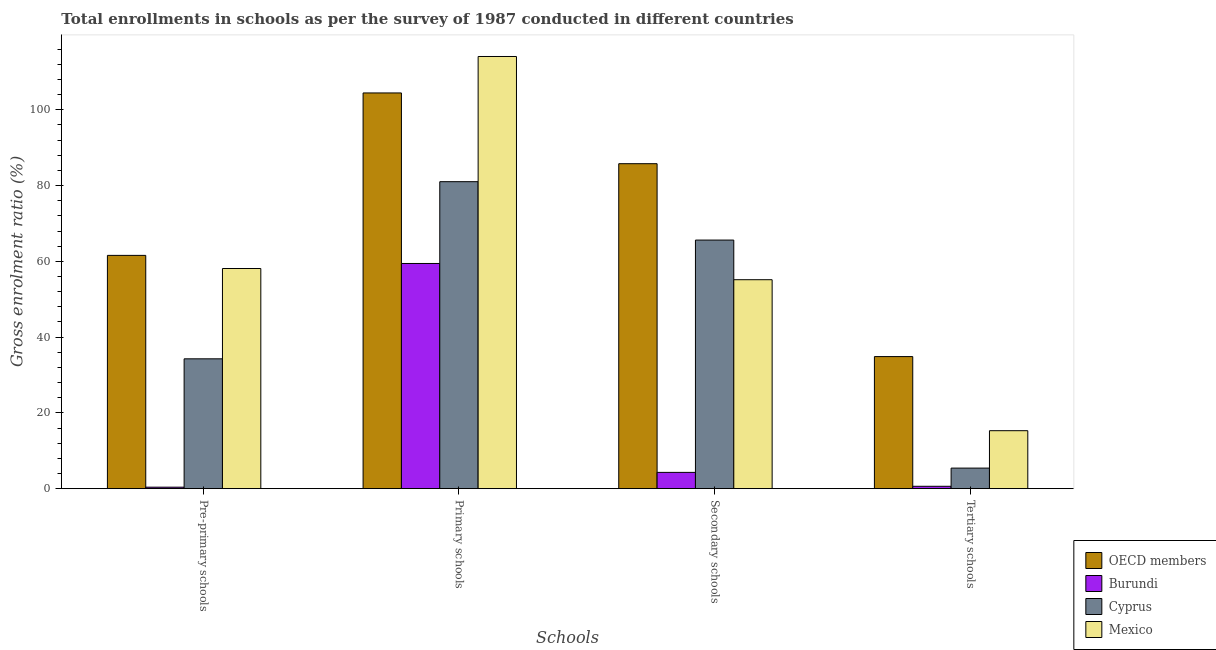How many different coloured bars are there?
Provide a succinct answer. 4. Are the number of bars per tick equal to the number of legend labels?
Provide a short and direct response. Yes. Are the number of bars on each tick of the X-axis equal?
Your response must be concise. Yes. How many bars are there on the 2nd tick from the left?
Keep it short and to the point. 4. What is the label of the 1st group of bars from the left?
Give a very brief answer. Pre-primary schools. What is the gross enrolment ratio in pre-primary schools in Cyprus?
Provide a succinct answer. 34.28. Across all countries, what is the maximum gross enrolment ratio in tertiary schools?
Your answer should be compact. 34.86. Across all countries, what is the minimum gross enrolment ratio in secondary schools?
Provide a succinct answer. 4.3. In which country was the gross enrolment ratio in secondary schools maximum?
Offer a terse response. OECD members. In which country was the gross enrolment ratio in pre-primary schools minimum?
Provide a short and direct response. Burundi. What is the total gross enrolment ratio in tertiary schools in the graph?
Provide a succinct answer. 56.23. What is the difference between the gross enrolment ratio in primary schools in OECD members and that in Cyprus?
Provide a short and direct response. 23.42. What is the difference between the gross enrolment ratio in tertiary schools in Burundi and the gross enrolment ratio in primary schools in Mexico?
Give a very brief answer. -113.45. What is the average gross enrolment ratio in pre-primary schools per country?
Give a very brief answer. 38.59. What is the difference between the gross enrolment ratio in secondary schools and gross enrolment ratio in primary schools in Cyprus?
Provide a succinct answer. -15.41. In how many countries, is the gross enrolment ratio in primary schools greater than 36 %?
Your answer should be very brief. 4. What is the ratio of the gross enrolment ratio in primary schools in Burundi to that in Mexico?
Your answer should be very brief. 0.52. Is the difference between the gross enrolment ratio in tertiary schools in Mexico and Burundi greater than the difference between the gross enrolment ratio in secondary schools in Mexico and Burundi?
Ensure brevity in your answer.  No. What is the difference between the highest and the second highest gross enrolment ratio in primary schools?
Keep it short and to the point. 9.62. What is the difference between the highest and the lowest gross enrolment ratio in secondary schools?
Offer a terse response. 81.48. What does the 3rd bar from the right in Pre-primary schools represents?
Make the answer very short. Burundi. How many bars are there?
Offer a very short reply. 16. Are all the bars in the graph horizontal?
Make the answer very short. No. What is the difference between two consecutive major ticks on the Y-axis?
Your response must be concise. 20. Are the values on the major ticks of Y-axis written in scientific E-notation?
Offer a terse response. No. Does the graph contain any zero values?
Your response must be concise. No. Does the graph contain grids?
Provide a succinct answer. No. How many legend labels are there?
Make the answer very short. 4. How are the legend labels stacked?
Make the answer very short. Vertical. What is the title of the graph?
Make the answer very short. Total enrollments in schools as per the survey of 1987 conducted in different countries. Does "Finland" appear as one of the legend labels in the graph?
Offer a very short reply. No. What is the label or title of the X-axis?
Give a very brief answer. Schools. What is the Gross enrolment ratio (%) in OECD members in Pre-primary schools?
Your answer should be compact. 61.58. What is the Gross enrolment ratio (%) in Burundi in Pre-primary schools?
Your response must be concise. 0.39. What is the Gross enrolment ratio (%) of Cyprus in Pre-primary schools?
Keep it short and to the point. 34.28. What is the Gross enrolment ratio (%) of Mexico in Pre-primary schools?
Provide a succinct answer. 58.11. What is the Gross enrolment ratio (%) in OECD members in Primary schools?
Offer a very short reply. 104.45. What is the Gross enrolment ratio (%) in Burundi in Primary schools?
Give a very brief answer. 59.44. What is the Gross enrolment ratio (%) in Cyprus in Primary schools?
Ensure brevity in your answer.  81.03. What is the Gross enrolment ratio (%) of Mexico in Primary schools?
Your answer should be very brief. 114.08. What is the Gross enrolment ratio (%) of OECD members in Secondary schools?
Offer a terse response. 85.78. What is the Gross enrolment ratio (%) of Burundi in Secondary schools?
Offer a terse response. 4.3. What is the Gross enrolment ratio (%) in Cyprus in Secondary schools?
Make the answer very short. 65.62. What is the Gross enrolment ratio (%) in Mexico in Secondary schools?
Ensure brevity in your answer.  55.15. What is the Gross enrolment ratio (%) of OECD members in Tertiary schools?
Your response must be concise. 34.86. What is the Gross enrolment ratio (%) of Burundi in Tertiary schools?
Offer a very short reply. 0.63. What is the Gross enrolment ratio (%) in Cyprus in Tertiary schools?
Make the answer very short. 5.43. What is the Gross enrolment ratio (%) in Mexico in Tertiary schools?
Your answer should be compact. 15.31. Across all Schools, what is the maximum Gross enrolment ratio (%) of OECD members?
Offer a terse response. 104.45. Across all Schools, what is the maximum Gross enrolment ratio (%) in Burundi?
Provide a succinct answer. 59.44. Across all Schools, what is the maximum Gross enrolment ratio (%) in Cyprus?
Offer a very short reply. 81.03. Across all Schools, what is the maximum Gross enrolment ratio (%) in Mexico?
Offer a terse response. 114.08. Across all Schools, what is the minimum Gross enrolment ratio (%) in OECD members?
Your answer should be very brief. 34.86. Across all Schools, what is the minimum Gross enrolment ratio (%) of Burundi?
Provide a succinct answer. 0.39. Across all Schools, what is the minimum Gross enrolment ratio (%) of Cyprus?
Keep it short and to the point. 5.43. Across all Schools, what is the minimum Gross enrolment ratio (%) in Mexico?
Offer a terse response. 15.31. What is the total Gross enrolment ratio (%) of OECD members in the graph?
Your answer should be compact. 286.68. What is the total Gross enrolment ratio (%) of Burundi in the graph?
Ensure brevity in your answer.  64.76. What is the total Gross enrolment ratio (%) of Cyprus in the graph?
Offer a terse response. 186.35. What is the total Gross enrolment ratio (%) of Mexico in the graph?
Give a very brief answer. 242.65. What is the difference between the Gross enrolment ratio (%) in OECD members in Pre-primary schools and that in Primary schools?
Keep it short and to the point. -42.88. What is the difference between the Gross enrolment ratio (%) of Burundi in Pre-primary schools and that in Primary schools?
Make the answer very short. -59.05. What is the difference between the Gross enrolment ratio (%) of Cyprus in Pre-primary schools and that in Primary schools?
Your response must be concise. -46.75. What is the difference between the Gross enrolment ratio (%) in Mexico in Pre-primary schools and that in Primary schools?
Your answer should be very brief. -55.96. What is the difference between the Gross enrolment ratio (%) in OECD members in Pre-primary schools and that in Secondary schools?
Your response must be concise. -24.2. What is the difference between the Gross enrolment ratio (%) in Burundi in Pre-primary schools and that in Secondary schools?
Provide a short and direct response. -3.91. What is the difference between the Gross enrolment ratio (%) of Cyprus in Pre-primary schools and that in Secondary schools?
Provide a succinct answer. -31.34. What is the difference between the Gross enrolment ratio (%) in Mexico in Pre-primary schools and that in Secondary schools?
Give a very brief answer. 2.96. What is the difference between the Gross enrolment ratio (%) of OECD members in Pre-primary schools and that in Tertiary schools?
Provide a short and direct response. 26.71. What is the difference between the Gross enrolment ratio (%) in Burundi in Pre-primary schools and that in Tertiary schools?
Ensure brevity in your answer.  -0.23. What is the difference between the Gross enrolment ratio (%) in Cyprus in Pre-primary schools and that in Tertiary schools?
Offer a terse response. 28.85. What is the difference between the Gross enrolment ratio (%) in Mexico in Pre-primary schools and that in Tertiary schools?
Your answer should be compact. 42.81. What is the difference between the Gross enrolment ratio (%) in OECD members in Primary schools and that in Secondary schools?
Offer a very short reply. 18.67. What is the difference between the Gross enrolment ratio (%) of Burundi in Primary schools and that in Secondary schools?
Your response must be concise. 55.14. What is the difference between the Gross enrolment ratio (%) in Cyprus in Primary schools and that in Secondary schools?
Your response must be concise. 15.41. What is the difference between the Gross enrolment ratio (%) of Mexico in Primary schools and that in Secondary schools?
Your answer should be compact. 58.92. What is the difference between the Gross enrolment ratio (%) of OECD members in Primary schools and that in Tertiary schools?
Give a very brief answer. 69.59. What is the difference between the Gross enrolment ratio (%) in Burundi in Primary schools and that in Tertiary schools?
Give a very brief answer. 58.81. What is the difference between the Gross enrolment ratio (%) in Cyprus in Primary schools and that in Tertiary schools?
Provide a short and direct response. 75.6. What is the difference between the Gross enrolment ratio (%) in Mexico in Primary schools and that in Tertiary schools?
Keep it short and to the point. 98.77. What is the difference between the Gross enrolment ratio (%) in OECD members in Secondary schools and that in Tertiary schools?
Keep it short and to the point. 50.92. What is the difference between the Gross enrolment ratio (%) of Burundi in Secondary schools and that in Tertiary schools?
Make the answer very short. 3.67. What is the difference between the Gross enrolment ratio (%) of Cyprus in Secondary schools and that in Tertiary schools?
Your answer should be compact. 60.19. What is the difference between the Gross enrolment ratio (%) in Mexico in Secondary schools and that in Tertiary schools?
Your answer should be compact. 39.85. What is the difference between the Gross enrolment ratio (%) of OECD members in Pre-primary schools and the Gross enrolment ratio (%) of Burundi in Primary schools?
Make the answer very short. 2.14. What is the difference between the Gross enrolment ratio (%) of OECD members in Pre-primary schools and the Gross enrolment ratio (%) of Cyprus in Primary schools?
Keep it short and to the point. -19.45. What is the difference between the Gross enrolment ratio (%) in OECD members in Pre-primary schools and the Gross enrolment ratio (%) in Mexico in Primary schools?
Make the answer very short. -52.5. What is the difference between the Gross enrolment ratio (%) in Burundi in Pre-primary schools and the Gross enrolment ratio (%) in Cyprus in Primary schools?
Ensure brevity in your answer.  -80.64. What is the difference between the Gross enrolment ratio (%) of Burundi in Pre-primary schools and the Gross enrolment ratio (%) of Mexico in Primary schools?
Keep it short and to the point. -113.68. What is the difference between the Gross enrolment ratio (%) of Cyprus in Pre-primary schools and the Gross enrolment ratio (%) of Mexico in Primary schools?
Your answer should be very brief. -79.8. What is the difference between the Gross enrolment ratio (%) in OECD members in Pre-primary schools and the Gross enrolment ratio (%) in Burundi in Secondary schools?
Provide a succinct answer. 57.28. What is the difference between the Gross enrolment ratio (%) of OECD members in Pre-primary schools and the Gross enrolment ratio (%) of Cyprus in Secondary schools?
Keep it short and to the point. -4.04. What is the difference between the Gross enrolment ratio (%) of OECD members in Pre-primary schools and the Gross enrolment ratio (%) of Mexico in Secondary schools?
Offer a terse response. 6.42. What is the difference between the Gross enrolment ratio (%) of Burundi in Pre-primary schools and the Gross enrolment ratio (%) of Cyprus in Secondary schools?
Provide a short and direct response. -65.22. What is the difference between the Gross enrolment ratio (%) in Burundi in Pre-primary schools and the Gross enrolment ratio (%) in Mexico in Secondary schools?
Give a very brief answer. -54.76. What is the difference between the Gross enrolment ratio (%) in Cyprus in Pre-primary schools and the Gross enrolment ratio (%) in Mexico in Secondary schools?
Your response must be concise. -20.88. What is the difference between the Gross enrolment ratio (%) in OECD members in Pre-primary schools and the Gross enrolment ratio (%) in Burundi in Tertiary schools?
Your answer should be very brief. 60.95. What is the difference between the Gross enrolment ratio (%) in OECD members in Pre-primary schools and the Gross enrolment ratio (%) in Cyprus in Tertiary schools?
Your answer should be very brief. 56.15. What is the difference between the Gross enrolment ratio (%) of OECD members in Pre-primary schools and the Gross enrolment ratio (%) of Mexico in Tertiary schools?
Ensure brevity in your answer.  46.27. What is the difference between the Gross enrolment ratio (%) in Burundi in Pre-primary schools and the Gross enrolment ratio (%) in Cyprus in Tertiary schools?
Keep it short and to the point. -5.04. What is the difference between the Gross enrolment ratio (%) in Burundi in Pre-primary schools and the Gross enrolment ratio (%) in Mexico in Tertiary schools?
Provide a short and direct response. -14.91. What is the difference between the Gross enrolment ratio (%) of Cyprus in Pre-primary schools and the Gross enrolment ratio (%) of Mexico in Tertiary schools?
Keep it short and to the point. 18.97. What is the difference between the Gross enrolment ratio (%) in OECD members in Primary schools and the Gross enrolment ratio (%) in Burundi in Secondary schools?
Your answer should be compact. 100.15. What is the difference between the Gross enrolment ratio (%) in OECD members in Primary schools and the Gross enrolment ratio (%) in Cyprus in Secondary schools?
Make the answer very short. 38.84. What is the difference between the Gross enrolment ratio (%) in OECD members in Primary schools and the Gross enrolment ratio (%) in Mexico in Secondary schools?
Your answer should be very brief. 49.3. What is the difference between the Gross enrolment ratio (%) in Burundi in Primary schools and the Gross enrolment ratio (%) in Cyprus in Secondary schools?
Ensure brevity in your answer.  -6.18. What is the difference between the Gross enrolment ratio (%) in Burundi in Primary schools and the Gross enrolment ratio (%) in Mexico in Secondary schools?
Ensure brevity in your answer.  4.29. What is the difference between the Gross enrolment ratio (%) in Cyprus in Primary schools and the Gross enrolment ratio (%) in Mexico in Secondary schools?
Your answer should be compact. 25.88. What is the difference between the Gross enrolment ratio (%) in OECD members in Primary schools and the Gross enrolment ratio (%) in Burundi in Tertiary schools?
Offer a very short reply. 103.82. What is the difference between the Gross enrolment ratio (%) in OECD members in Primary schools and the Gross enrolment ratio (%) in Cyprus in Tertiary schools?
Your answer should be compact. 99.02. What is the difference between the Gross enrolment ratio (%) of OECD members in Primary schools and the Gross enrolment ratio (%) of Mexico in Tertiary schools?
Make the answer very short. 89.15. What is the difference between the Gross enrolment ratio (%) of Burundi in Primary schools and the Gross enrolment ratio (%) of Cyprus in Tertiary schools?
Ensure brevity in your answer.  54.01. What is the difference between the Gross enrolment ratio (%) in Burundi in Primary schools and the Gross enrolment ratio (%) in Mexico in Tertiary schools?
Your answer should be very brief. 44.14. What is the difference between the Gross enrolment ratio (%) of Cyprus in Primary schools and the Gross enrolment ratio (%) of Mexico in Tertiary schools?
Your response must be concise. 65.72. What is the difference between the Gross enrolment ratio (%) in OECD members in Secondary schools and the Gross enrolment ratio (%) in Burundi in Tertiary schools?
Provide a succinct answer. 85.15. What is the difference between the Gross enrolment ratio (%) of OECD members in Secondary schools and the Gross enrolment ratio (%) of Cyprus in Tertiary schools?
Ensure brevity in your answer.  80.35. What is the difference between the Gross enrolment ratio (%) in OECD members in Secondary schools and the Gross enrolment ratio (%) in Mexico in Tertiary schools?
Give a very brief answer. 70.47. What is the difference between the Gross enrolment ratio (%) in Burundi in Secondary schools and the Gross enrolment ratio (%) in Cyprus in Tertiary schools?
Keep it short and to the point. -1.13. What is the difference between the Gross enrolment ratio (%) of Burundi in Secondary schools and the Gross enrolment ratio (%) of Mexico in Tertiary schools?
Your answer should be very brief. -11.01. What is the difference between the Gross enrolment ratio (%) of Cyprus in Secondary schools and the Gross enrolment ratio (%) of Mexico in Tertiary schools?
Give a very brief answer. 50.31. What is the average Gross enrolment ratio (%) of OECD members per Schools?
Make the answer very short. 71.67. What is the average Gross enrolment ratio (%) in Burundi per Schools?
Provide a succinct answer. 16.19. What is the average Gross enrolment ratio (%) in Cyprus per Schools?
Make the answer very short. 46.59. What is the average Gross enrolment ratio (%) in Mexico per Schools?
Your answer should be compact. 60.66. What is the difference between the Gross enrolment ratio (%) of OECD members and Gross enrolment ratio (%) of Burundi in Pre-primary schools?
Make the answer very short. 61.18. What is the difference between the Gross enrolment ratio (%) of OECD members and Gross enrolment ratio (%) of Cyprus in Pre-primary schools?
Make the answer very short. 27.3. What is the difference between the Gross enrolment ratio (%) of OECD members and Gross enrolment ratio (%) of Mexico in Pre-primary schools?
Give a very brief answer. 3.46. What is the difference between the Gross enrolment ratio (%) of Burundi and Gross enrolment ratio (%) of Cyprus in Pre-primary schools?
Your answer should be very brief. -33.88. What is the difference between the Gross enrolment ratio (%) of Burundi and Gross enrolment ratio (%) of Mexico in Pre-primary schools?
Ensure brevity in your answer.  -57.72. What is the difference between the Gross enrolment ratio (%) in Cyprus and Gross enrolment ratio (%) in Mexico in Pre-primary schools?
Your answer should be very brief. -23.84. What is the difference between the Gross enrolment ratio (%) of OECD members and Gross enrolment ratio (%) of Burundi in Primary schools?
Your response must be concise. 45.01. What is the difference between the Gross enrolment ratio (%) of OECD members and Gross enrolment ratio (%) of Cyprus in Primary schools?
Your response must be concise. 23.42. What is the difference between the Gross enrolment ratio (%) in OECD members and Gross enrolment ratio (%) in Mexico in Primary schools?
Offer a terse response. -9.62. What is the difference between the Gross enrolment ratio (%) of Burundi and Gross enrolment ratio (%) of Cyprus in Primary schools?
Give a very brief answer. -21.59. What is the difference between the Gross enrolment ratio (%) of Burundi and Gross enrolment ratio (%) of Mexico in Primary schools?
Ensure brevity in your answer.  -54.64. What is the difference between the Gross enrolment ratio (%) in Cyprus and Gross enrolment ratio (%) in Mexico in Primary schools?
Make the answer very short. -33.05. What is the difference between the Gross enrolment ratio (%) in OECD members and Gross enrolment ratio (%) in Burundi in Secondary schools?
Make the answer very short. 81.48. What is the difference between the Gross enrolment ratio (%) of OECD members and Gross enrolment ratio (%) of Cyprus in Secondary schools?
Give a very brief answer. 20.16. What is the difference between the Gross enrolment ratio (%) of OECD members and Gross enrolment ratio (%) of Mexico in Secondary schools?
Your answer should be compact. 30.63. What is the difference between the Gross enrolment ratio (%) in Burundi and Gross enrolment ratio (%) in Cyprus in Secondary schools?
Give a very brief answer. -61.32. What is the difference between the Gross enrolment ratio (%) of Burundi and Gross enrolment ratio (%) of Mexico in Secondary schools?
Provide a short and direct response. -50.85. What is the difference between the Gross enrolment ratio (%) of Cyprus and Gross enrolment ratio (%) of Mexico in Secondary schools?
Ensure brevity in your answer.  10.46. What is the difference between the Gross enrolment ratio (%) of OECD members and Gross enrolment ratio (%) of Burundi in Tertiary schools?
Offer a very short reply. 34.24. What is the difference between the Gross enrolment ratio (%) in OECD members and Gross enrolment ratio (%) in Cyprus in Tertiary schools?
Your response must be concise. 29.44. What is the difference between the Gross enrolment ratio (%) in OECD members and Gross enrolment ratio (%) in Mexico in Tertiary schools?
Make the answer very short. 19.56. What is the difference between the Gross enrolment ratio (%) in Burundi and Gross enrolment ratio (%) in Cyprus in Tertiary schools?
Provide a succinct answer. -4.8. What is the difference between the Gross enrolment ratio (%) in Burundi and Gross enrolment ratio (%) in Mexico in Tertiary schools?
Keep it short and to the point. -14.68. What is the difference between the Gross enrolment ratio (%) of Cyprus and Gross enrolment ratio (%) of Mexico in Tertiary schools?
Your answer should be very brief. -9.88. What is the ratio of the Gross enrolment ratio (%) of OECD members in Pre-primary schools to that in Primary schools?
Make the answer very short. 0.59. What is the ratio of the Gross enrolment ratio (%) in Burundi in Pre-primary schools to that in Primary schools?
Offer a very short reply. 0.01. What is the ratio of the Gross enrolment ratio (%) of Cyprus in Pre-primary schools to that in Primary schools?
Ensure brevity in your answer.  0.42. What is the ratio of the Gross enrolment ratio (%) in Mexico in Pre-primary schools to that in Primary schools?
Your response must be concise. 0.51. What is the ratio of the Gross enrolment ratio (%) in OECD members in Pre-primary schools to that in Secondary schools?
Offer a terse response. 0.72. What is the ratio of the Gross enrolment ratio (%) of Burundi in Pre-primary schools to that in Secondary schools?
Provide a succinct answer. 0.09. What is the ratio of the Gross enrolment ratio (%) in Cyprus in Pre-primary schools to that in Secondary schools?
Your answer should be compact. 0.52. What is the ratio of the Gross enrolment ratio (%) of Mexico in Pre-primary schools to that in Secondary schools?
Keep it short and to the point. 1.05. What is the ratio of the Gross enrolment ratio (%) of OECD members in Pre-primary schools to that in Tertiary schools?
Offer a terse response. 1.77. What is the ratio of the Gross enrolment ratio (%) in Burundi in Pre-primary schools to that in Tertiary schools?
Make the answer very short. 0.63. What is the ratio of the Gross enrolment ratio (%) in Cyprus in Pre-primary schools to that in Tertiary schools?
Your answer should be compact. 6.31. What is the ratio of the Gross enrolment ratio (%) in Mexico in Pre-primary schools to that in Tertiary schools?
Provide a succinct answer. 3.8. What is the ratio of the Gross enrolment ratio (%) in OECD members in Primary schools to that in Secondary schools?
Your answer should be compact. 1.22. What is the ratio of the Gross enrolment ratio (%) in Burundi in Primary schools to that in Secondary schools?
Keep it short and to the point. 13.82. What is the ratio of the Gross enrolment ratio (%) of Cyprus in Primary schools to that in Secondary schools?
Offer a terse response. 1.23. What is the ratio of the Gross enrolment ratio (%) of Mexico in Primary schools to that in Secondary schools?
Your response must be concise. 2.07. What is the ratio of the Gross enrolment ratio (%) of OECD members in Primary schools to that in Tertiary schools?
Offer a terse response. 3. What is the ratio of the Gross enrolment ratio (%) in Burundi in Primary schools to that in Tertiary schools?
Ensure brevity in your answer.  94.54. What is the ratio of the Gross enrolment ratio (%) in Cyprus in Primary schools to that in Tertiary schools?
Keep it short and to the point. 14.92. What is the ratio of the Gross enrolment ratio (%) of Mexico in Primary schools to that in Tertiary schools?
Provide a succinct answer. 7.45. What is the ratio of the Gross enrolment ratio (%) of OECD members in Secondary schools to that in Tertiary schools?
Keep it short and to the point. 2.46. What is the ratio of the Gross enrolment ratio (%) of Burundi in Secondary schools to that in Tertiary schools?
Provide a short and direct response. 6.84. What is the ratio of the Gross enrolment ratio (%) of Cyprus in Secondary schools to that in Tertiary schools?
Provide a short and direct response. 12.09. What is the ratio of the Gross enrolment ratio (%) in Mexico in Secondary schools to that in Tertiary schools?
Offer a terse response. 3.6. What is the difference between the highest and the second highest Gross enrolment ratio (%) of OECD members?
Your answer should be compact. 18.67. What is the difference between the highest and the second highest Gross enrolment ratio (%) in Burundi?
Your response must be concise. 55.14. What is the difference between the highest and the second highest Gross enrolment ratio (%) of Cyprus?
Provide a short and direct response. 15.41. What is the difference between the highest and the second highest Gross enrolment ratio (%) of Mexico?
Make the answer very short. 55.96. What is the difference between the highest and the lowest Gross enrolment ratio (%) in OECD members?
Keep it short and to the point. 69.59. What is the difference between the highest and the lowest Gross enrolment ratio (%) of Burundi?
Give a very brief answer. 59.05. What is the difference between the highest and the lowest Gross enrolment ratio (%) of Cyprus?
Your answer should be very brief. 75.6. What is the difference between the highest and the lowest Gross enrolment ratio (%) of Mexico?
Provide a short and direct response. 98.77. 